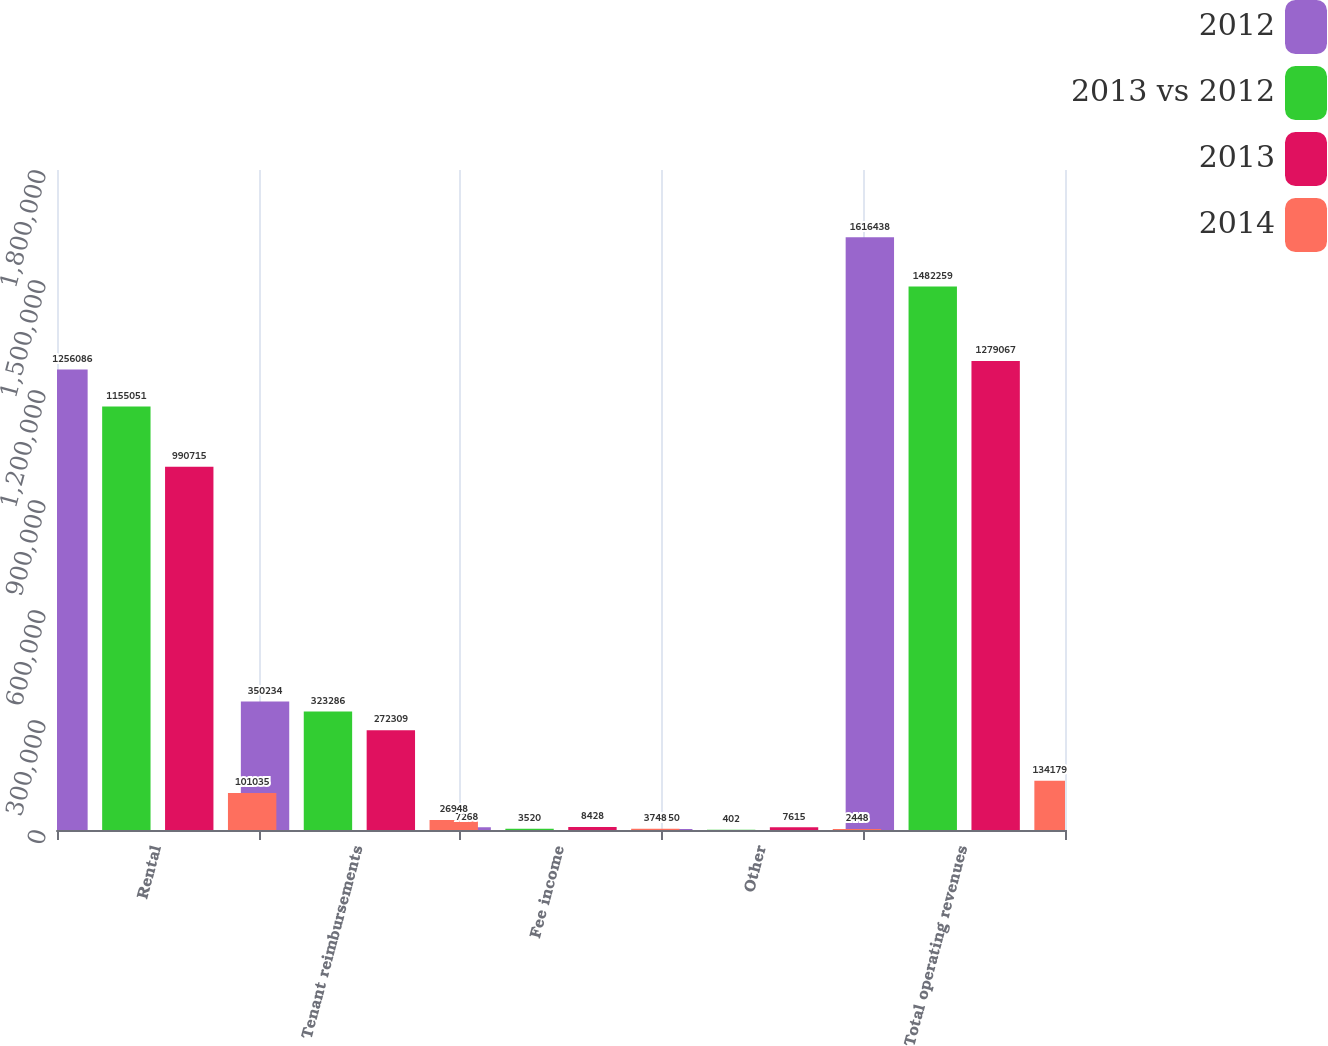Convert chart. <chart><loc_0><loc_0><loc_500><loc_500><stacked_bar_chart><ecel><fcel>Rental<fcel>Tenant reimbursements<fcel>Fee income<fcel>Other<fcel>Total operating revenues<nl><fcel>2012<fcel>1.25609e+06<fcel>350234<fcel>7268<fcel>2850<fcel>1.61644e+06<nl><fcel>2013 vs 2012<fcel>1.15505e+06<fcel>323286<fcel>3520<fcel>402<fcel>1.48226e+06<nl><fcel>2013<fcel>990715<fcel>272309<fcel>8428<fcel>7615<fcel>1.27907e+06<nl><fcel>2014<fcel>101035<fcel>26948<fcel>3748<fcel>2448<fcel>134179<nl></chart> 